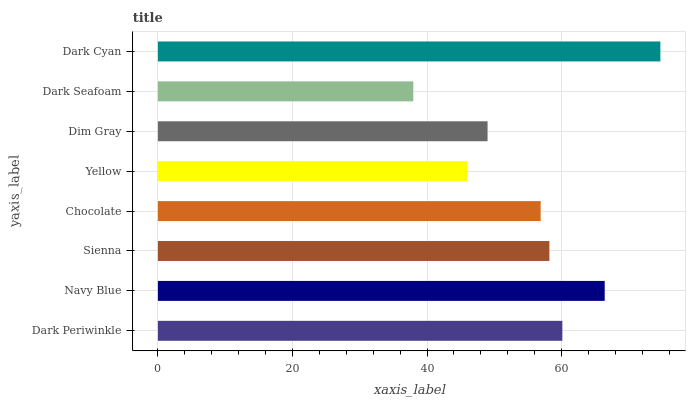Is Dark Seafoam the minimum?
Answer yes or no. Yes. Is Dark Cyan the maximum?
Answer yes or no. Yes. Is Navy Blue the minimum?
Answer yes or no. No. Is Navy Blue the maximum?
Answer yes or no. No. Is Navy Blue greater than Dark Periwinkle?
Answer yes or no. Yes. Is Dark Periwinkle less than Navy Blue?
Answer yes or no. Yes. Is Dark Periwinkle greater than Navy Blue?
Answer yes or no. No. Is Navy Blue less than Dark Periwinkle?
Answer yes or no. No. Is Sienna the high median?
Answer yes or no. Yes. Is Chocolate the low median?
Answer yes or no. Yes. Is Chocolate the high median?
Answer yes or no. No. Is Yellow the low median?
Answer yes or no. No. 